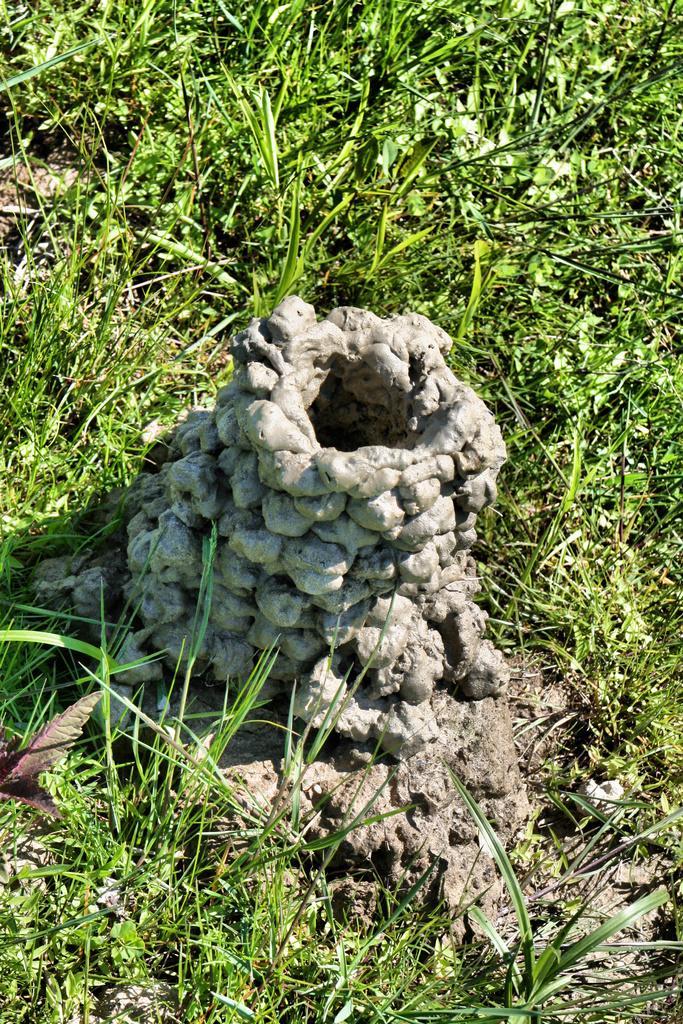In one or two sentences, can you explain what this image depicts? In the picture we can see a mud made hole on the grass surface area. 